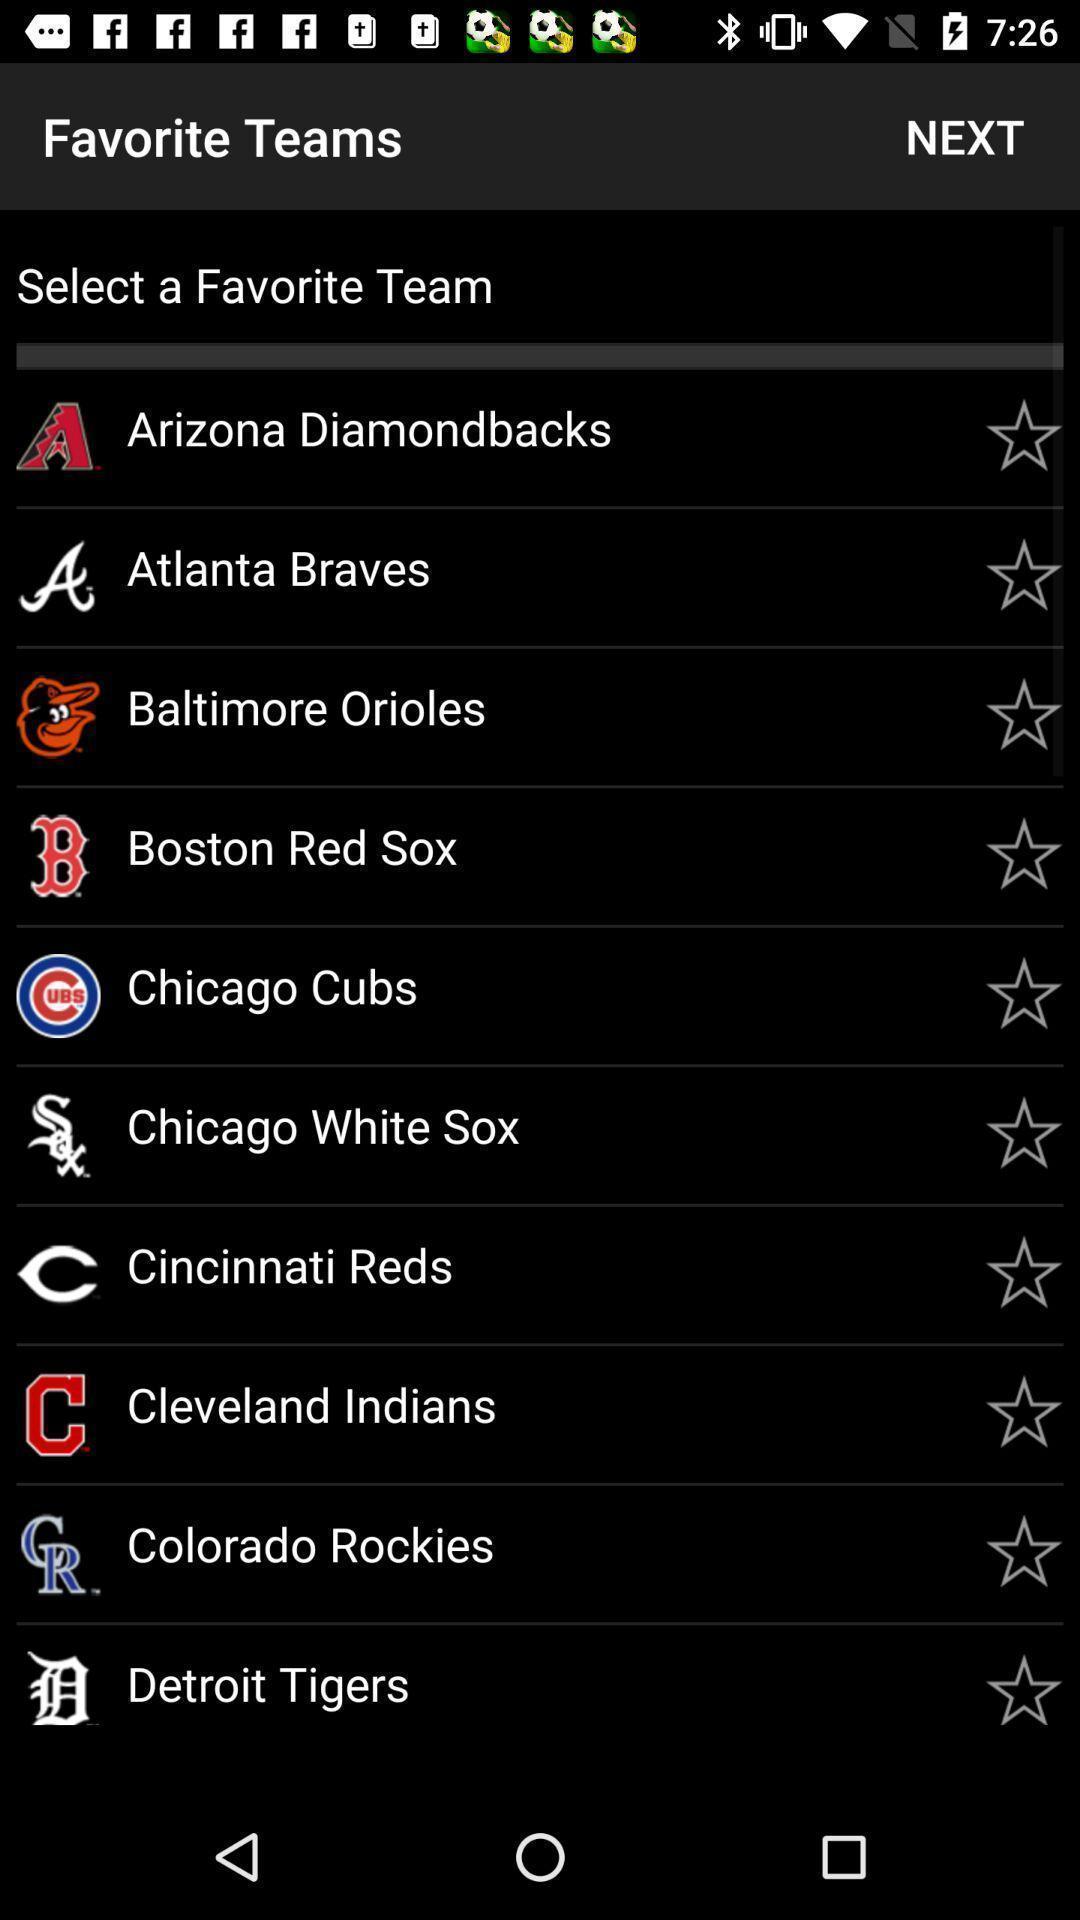Summarize the main components in this picture. Screen shows list of teams in sports app. 